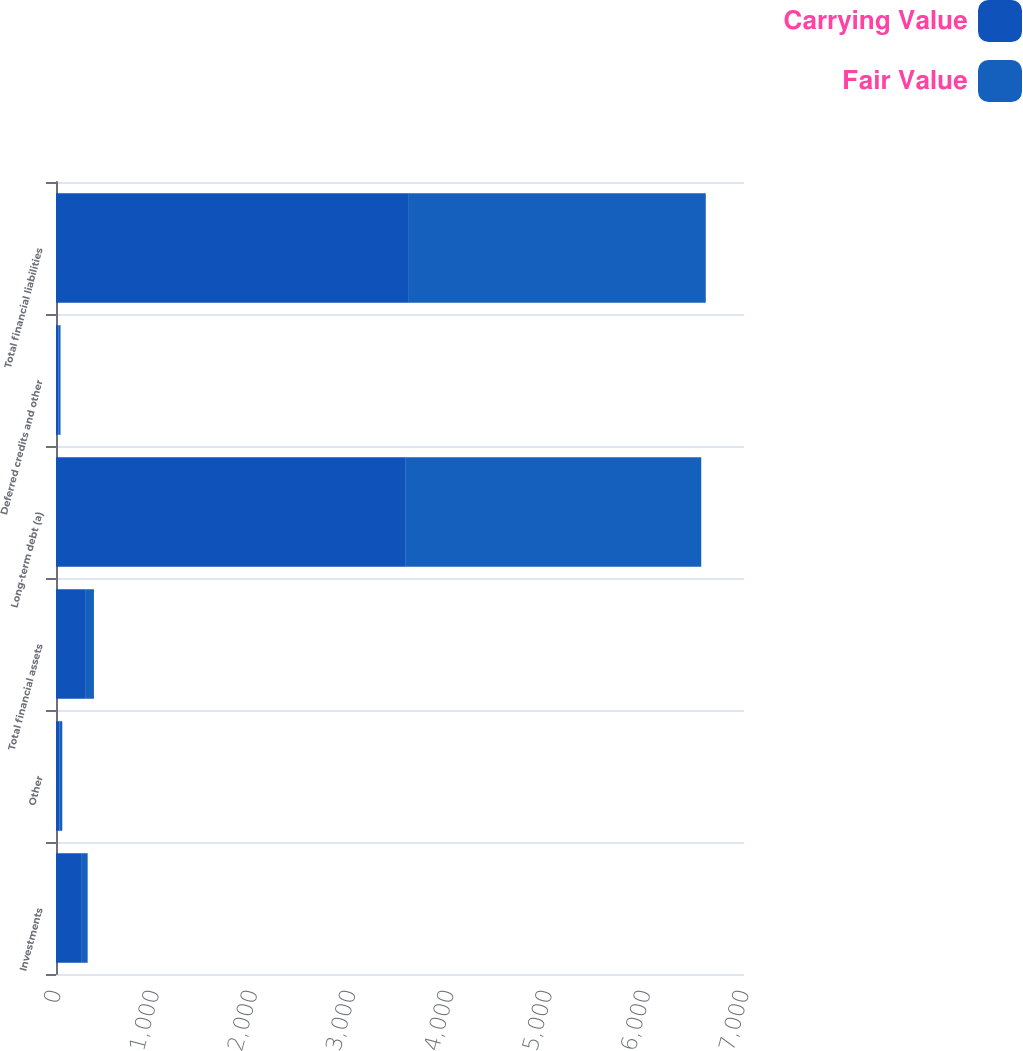Convert chart. <chart><loc_0><loc_0><loc_500><loc_500><stacked_bar_chart><ecel><fcel>Investments<fcel>Other<fcel>Total financial assets<fcel>Long-term debt (a)<fcel>Deferred credits and other<fcel>Total financial liabilities<nl><fcel>Carrying Value<fcel>263<fcel>33<fcel>296<fcel>3559<fcel>23<fcel>3582<nl><fcel>Fair Value<fcel>59<fcel>31<fcel>90<fcel>3006<fcel>23<fcel>3029<nl></chart> 